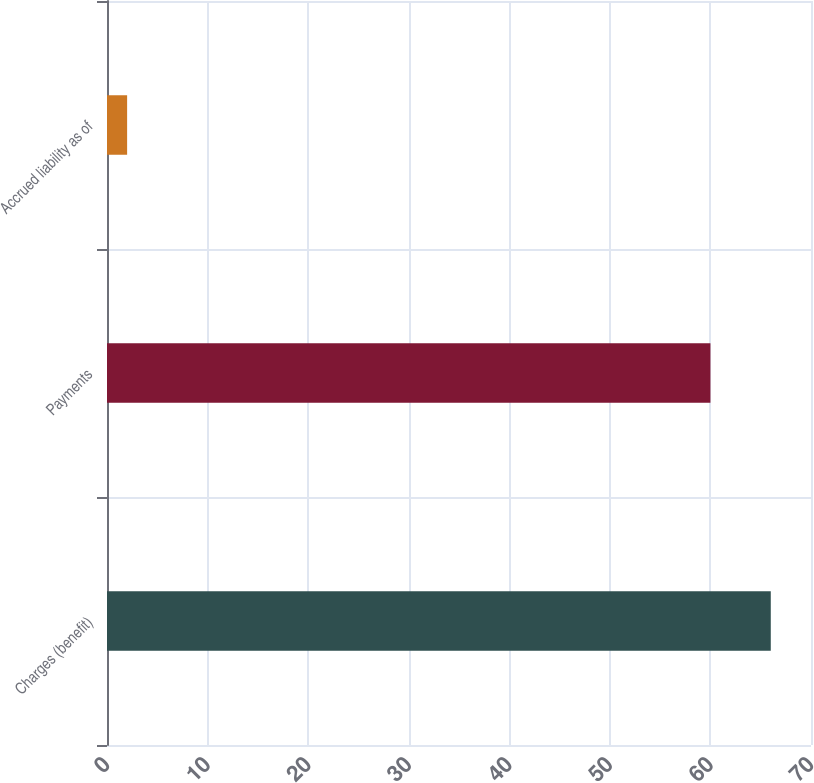Convert chart to OTSL. <chart><loc_0><loc_0><loc_500><loc_500><bar_chart><fcel>Charges (benefit)<fcel>Payments<fcel>Accrued liability as of<nl><fcel>66<fcel>60<fcel>2<nl></chart> 